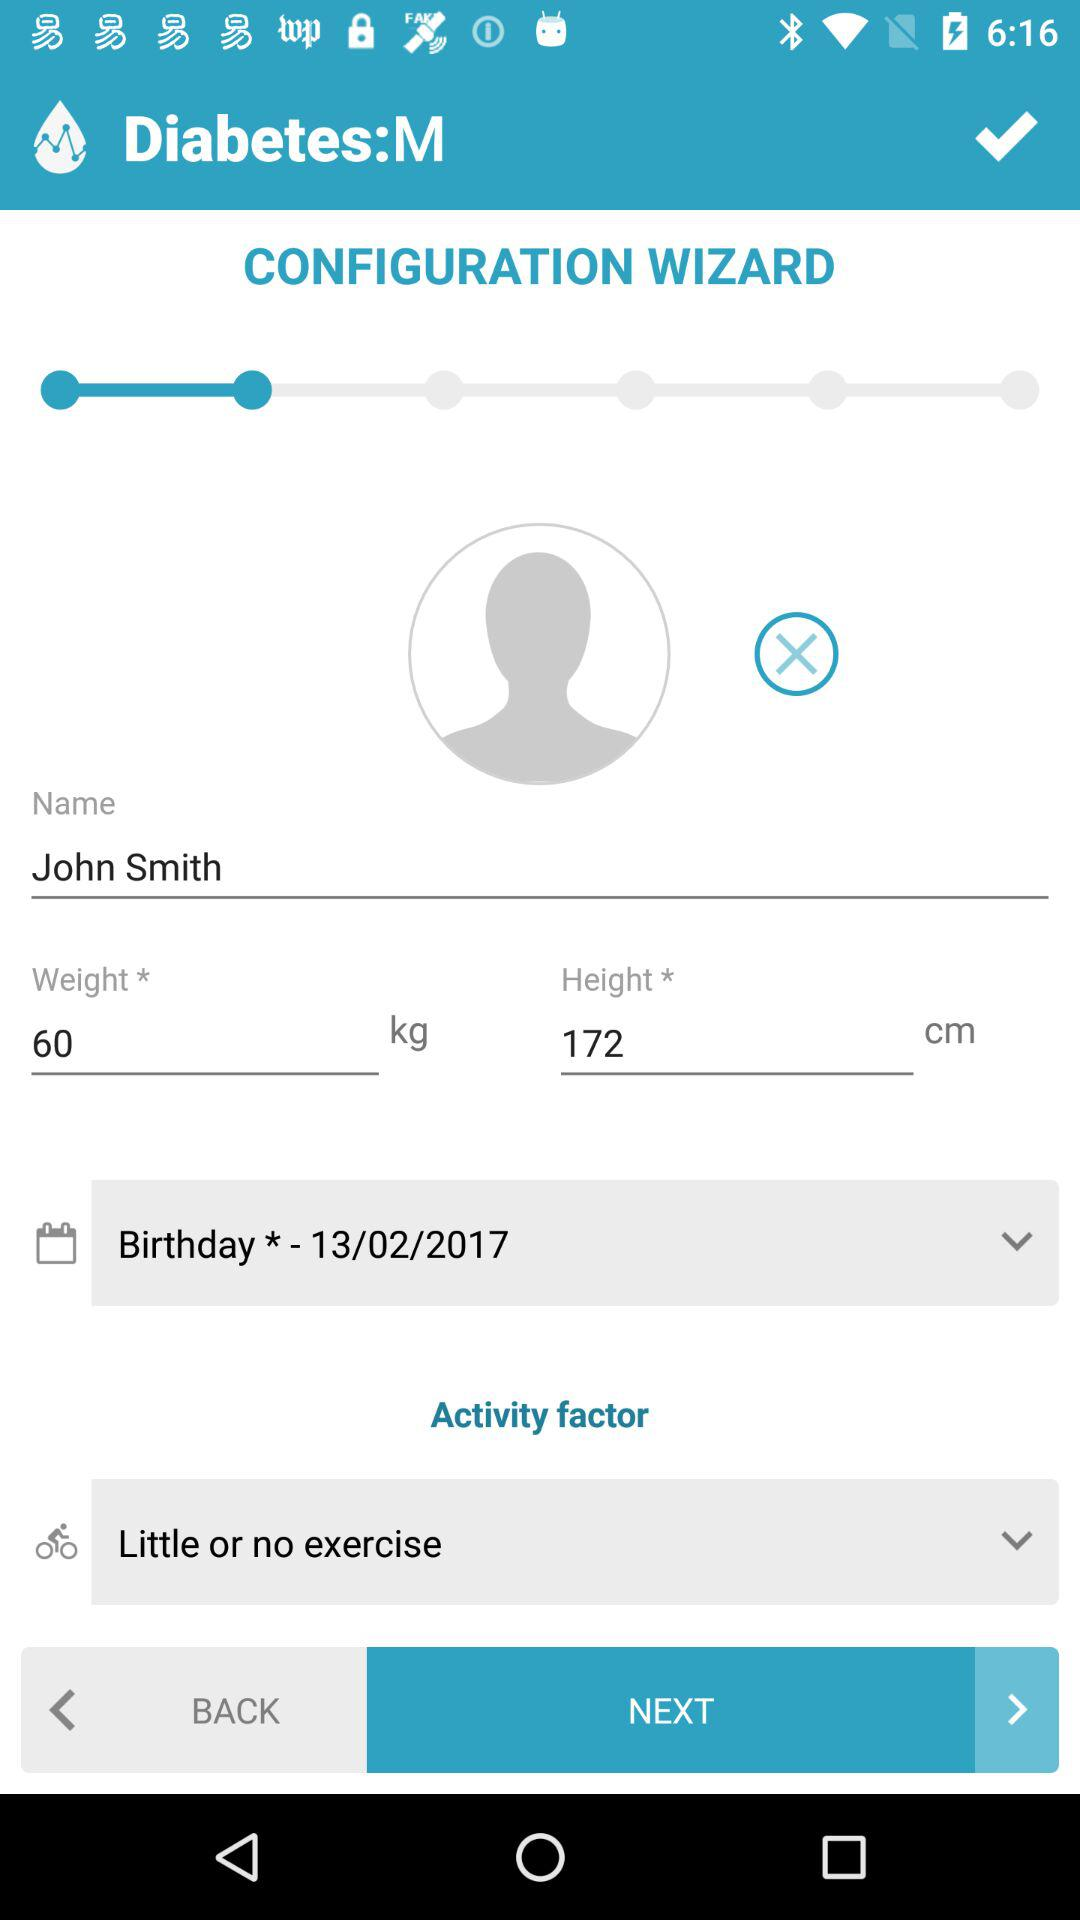What activity factor is selected? The selected activity factor is "Little or no exercise". 